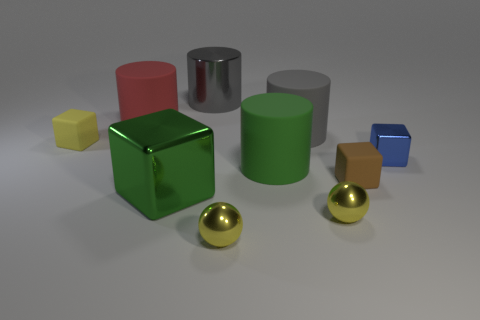Is there a blue metal cylinder that has the same size as the green rubber object?
Your response must be concise. No. Is the size of the metallic cube left of the brown rubber thing the same as the big gray metallic object?
Your answer should be compact. Yes. The blue block is what size?
Offer a terse response. Small. What color is the large cylinder behind the large matte cylinder that is behind the large cylinder right of the green matte cylinder?
Provide a short and direct response. Gray. Does the small block that is on the left side of the red cylinder have the same color as the metal cylinder?
Provide a succinct answer. No. What number of blocks are right of the gray shiny cylinder and in front of the big green cylinder?
Your response must be concise. 1. There is another metal object that is the same shape as the green metal thing; what is its size?
Offer a terse response. Small. There is a small block to the left of the red thing that is left of the small blue metallic object; how many cubes are right of it?
Your answer should be very brief. 3. There is a big thing behind the cylinder on the left side of the big green metal thing; what color is it?
Your answer should be compact. Gray. What number of other things are made of the same material as the tiny blue object?
Offer a very short reply. 4. 